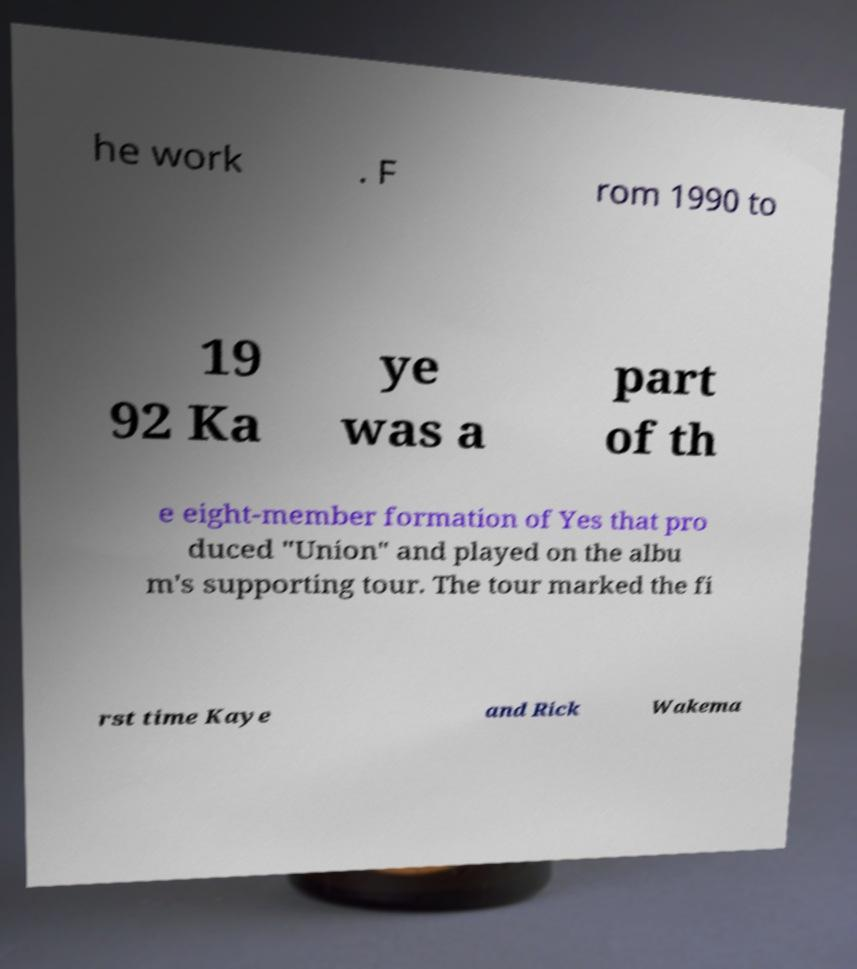Please read and relay the text visible in this image. What does it say? he work . F rom 1990 to 19 92 Ka ye was a part of th e eight-member formation of Yes that pro duced "Union" and played on the albu m's supporting tour. The tour marked the fi rst time Kaye and Rick Wakema 